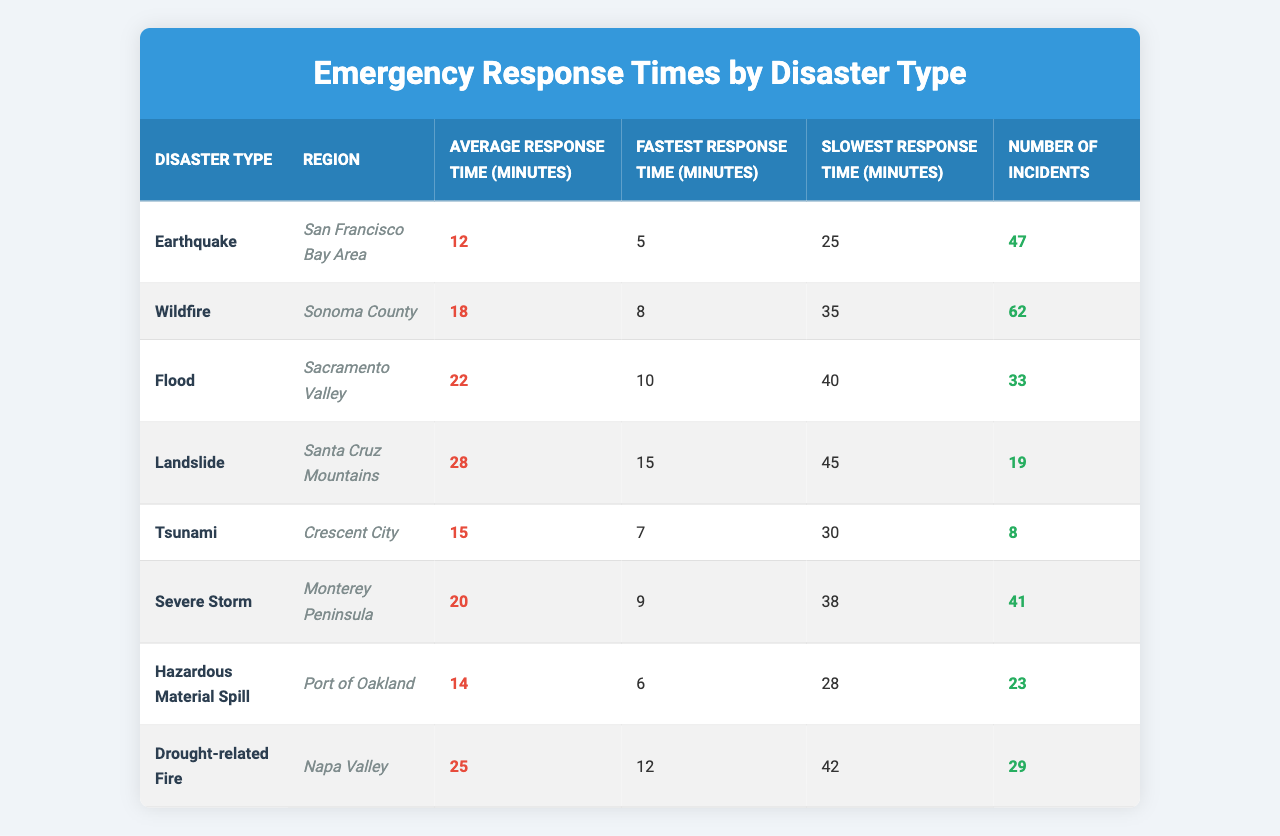What is the average response time for earthquakes in the San Francisco Bay Area? According to the table, the average response time for earthquakes in the San Francisco Bay Area is 12 minutes, as specified in the corresponding row for that disaster type.
Answer: 12 minutes What was the fastest response time recorded for wildfires in Sonoma County? The table shows that the fastest response time for wildfires in Sonoma County is 8 minutes, which is found in the relevant row.
Answer: 8 minutes How many incidents of landslides occurred in the Santa Cruz Mountains? The table indicates there were 19 incidents of landslides in the Santa Cruz Mountains, as shown in the respective row under "Number of Incidents."
Answer: 19 incidents Which disaster type has the longest average response time? By comparing the average response times listed in the table, landslides have the longest average response time of 28 minutes, found in its respective row.
Answer: Landslides Is the fastest response time for tsunamis greater than the fastest response time for earthquakes? The fastest response time for tsunamis is 7 minutes, while for earthquakes, it is 5 minutes. Since 7 is greater than 5, the statement is true.
Answer: Yes What is the difference between the average response time of wildfires and drought-related fires? The average response time for wildfires is 18 minutes, and for drought-related fires, it is 25 minutes. The difference is 25 - 18 = 7 minutes.
Answer: 7 minutes How many total incidents occurred for the three disaster types with the longest average response times? The three disaster types with the longest average response times are landslides (19 incidents), drought-related fires (29 incidents), and floods (33 incidents). Adding these gives: 19 + 29 + 33 = 81 incidents total.
Answer: 81 incidents Does the average response time for hazardous material spills exceed 15 minutes? The average response time for hazardous material spills is 14 minutes. Since 14 is less than 15, the answer is no.
Answer: No What is the average response time across all the disaster types listed in the table? To find the average response time, we sum the average response times: 12 + 18 + 22 + 28 + 15 + 20 + 14 + 25 = 154 minutes. Since there are 8 disaster types, we divide 154 by 8, resulting in 19.25 minutes average response time.
Answer: 19.25 minutes Which disaster type had the highest discrepancy between the fastest and slowest response times? To find the discrepancy, we calculate the difference between the fastest and slowest response times for each disaster type and compare them. The discrepancy for drought-related fires is 42 - 12 = 30 minutes, which is the highest among all.
Answer: Drought-related fires 